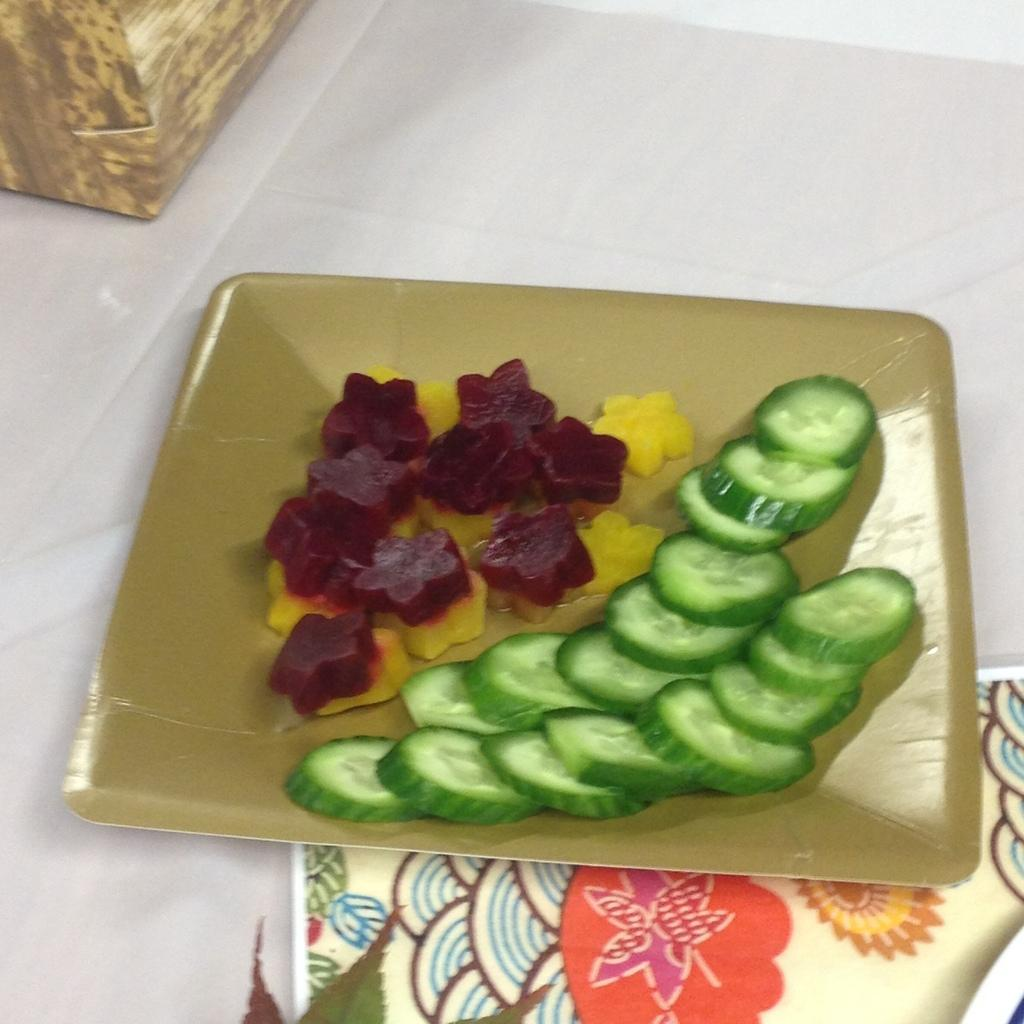What type of food can be seen in the image? There are cucumber pieces in the image. Are there any other types of vegetables present? Yes, there are other vegetables in the image. How are the vegetables arranged or displayed? The vegetables are on a plate. What type of dog can be seen exchanging the vegetables in the image? There is no dog present in the image, and the vegetables are not being exchanged. 